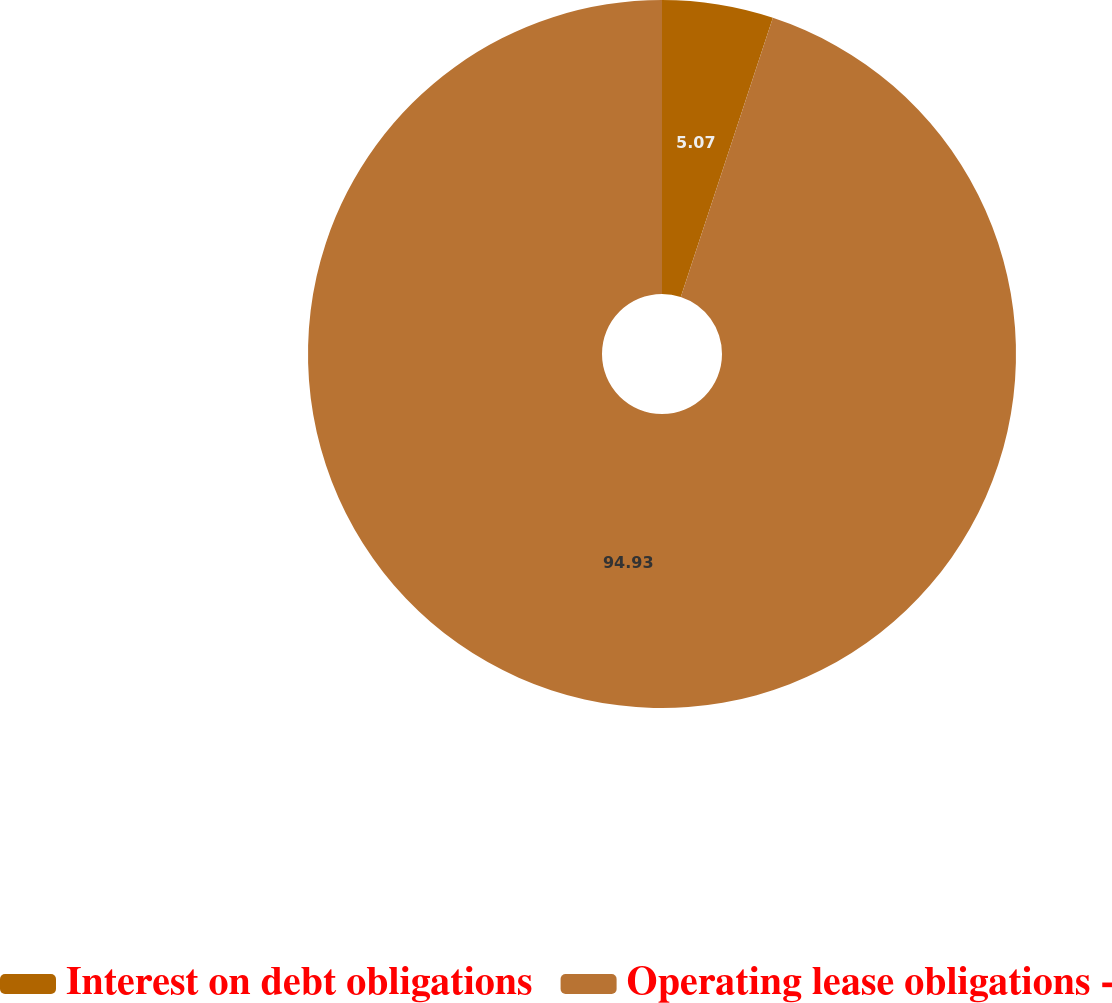<chart> <loc_0><loc_0><loc_500><loc_500><pie_chart><fcel>Interest on debt obligations<fcel>Operating lease obligations -<nl><fcel>5.07%<fcel>94.93%<nl></chart> 